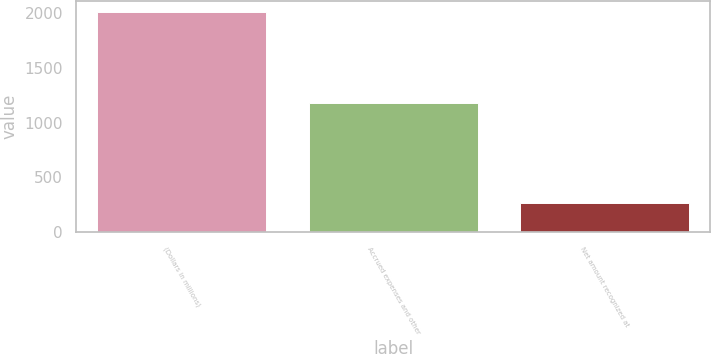Convert chart to OTSL. <chart><loc_0><loc_0><loc_500><loc_500><bar_chart><fcel>(Dollars in millions)<fcel>Accrued expenses and other<fcel>Net amount recognized at<nl><fcel>2012<fcel>1179<fcel>271<nl></chart> 